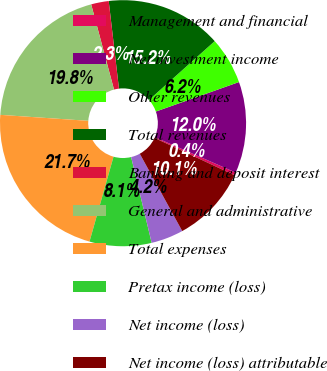Convert chart. <chart><loc_0><loc_0><loc_500><loc_500><pie_chart><fcel>Management and financial<fcel>Net investment income<fcel>Other revenues<fcel>Total revenues<fcel>Banking and deposit interest<fcel>General and administrative<fcel>Total expenses<fcel>Pretax income (loss)<fcel>Net income (loss)<fcel>Net income (loss) attributable<nl><fcel>0.38%<fcel>12.0%<fcel>6.19%<fcel>15.24%<fcel>2.31%<fcel>19.75%<fcel>21.69%<fcel>8.13%<fcel>4.25%<fcel>10.06%<nl></chart> 